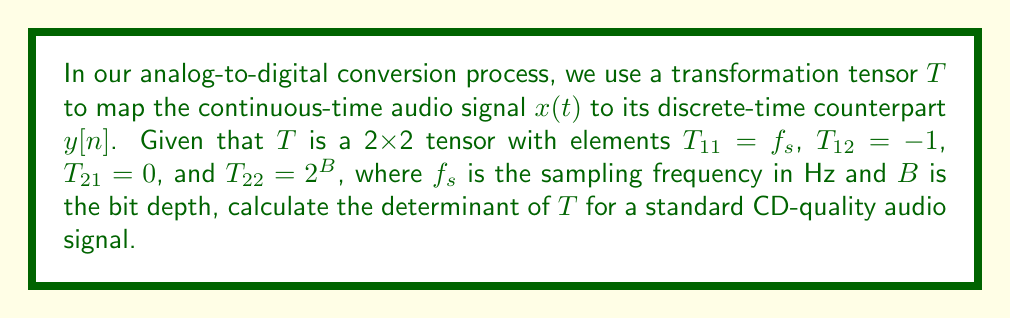Solve this math problem. Let's approach this step-by-step:

1) The transformation tensor $T$ is given as:

   $$T = \begin{bmatrix}
   T_{11} & T_{12} \\
   T_{21} & T_{22}
   \end{bmatrix} = \begin{bmatrix}
   f_s & -1 \\
   0 & 2^B
   \end{bmatrix}$$

2) For a standard CD-quality audio signal:
   - Sampling frequency $f_s = 44100$ Hz
   - Bit depth $B = 16$ bits

3) Substituting these values:

   $$T = \begin{bmatrix}
   44100 & -1 \\
   0 & 2^{16}
   \end{bmatrix}$$

4) The determinant of a 2x2 matrix is calculated as:

   $$\det(T) = T_{11}T_{22} - T_{12}T_{21}$$

5) Substituting the values:

   $$\det(T) = (44100)(2^{16}) - (-1)(0)$$

6) Simplify:
   
   $$\det(T) = 44100 \cdot 65536 = 2,890,137,600$$

Thus, the determinant of the transformation tensor $T$ for a standard CD-quality audio signal is 2,890,137,600.
Answer: 2,890,137,600 